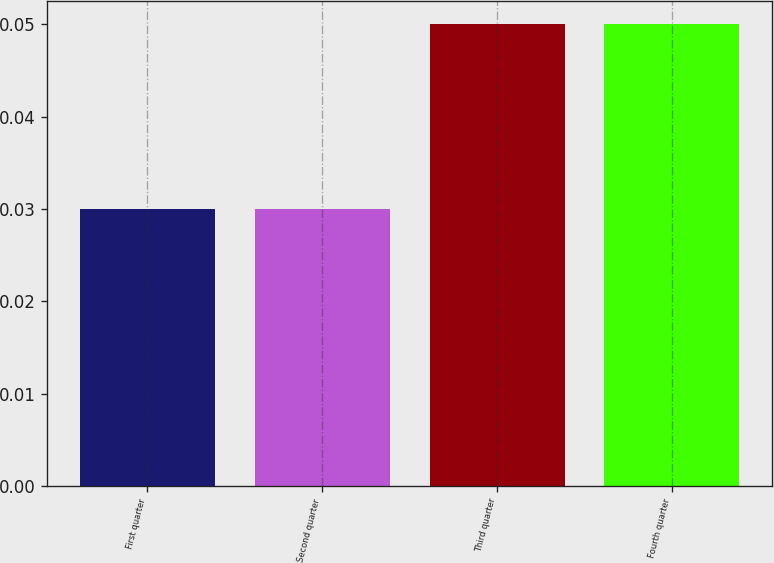<chart> <loc_0><loc_0><loc_500><loc_500><bar_chart><fcel>First quarter<fcel>Second quarter<fcel>Third quarter<fcel>Fourth quarter<nl><fcel>0.03<fcel>0.03<fcel>0.05<fcel>0.05<nl></chart> 